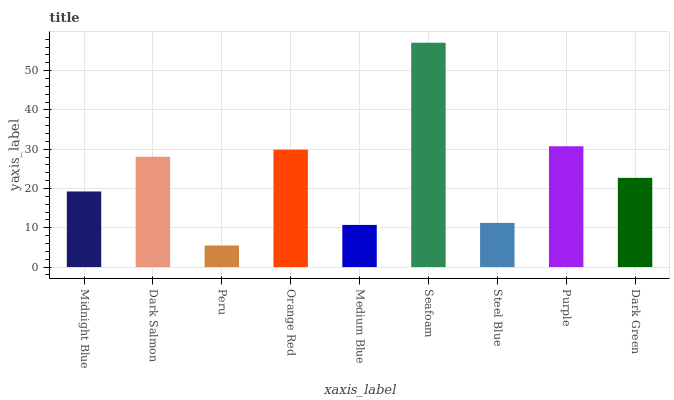Is Peru the minimum?
Answer yes or no. Yes. Is Seafoam the maximum?
Answer yes or no. Yes. Is Dark Salmon the minimum?
Answer yes or no. No. Is Dark Salmon the maximum?
Answer yes or no. No. Is Dark Salmon greater than Midnight Blue?
Answer yes or no. Yes. Is Midnight Blue less than Dark Salmon?
Answer yes or no. Yes. Is Midnight Blue greater than Dark Salmon?
Answer yes or no. No. Is Dark Salmon less than Midnight Blue?
Answer yes or no. No. Is Dark Green the high median?
Answer yes or no. Yes. Is Dark Green the low median?
Answer yes or no. Yes. Is Seafoam the high median?
Answer yes or no. No. Is Seafoam the low median?
Answer yes or no. No. 